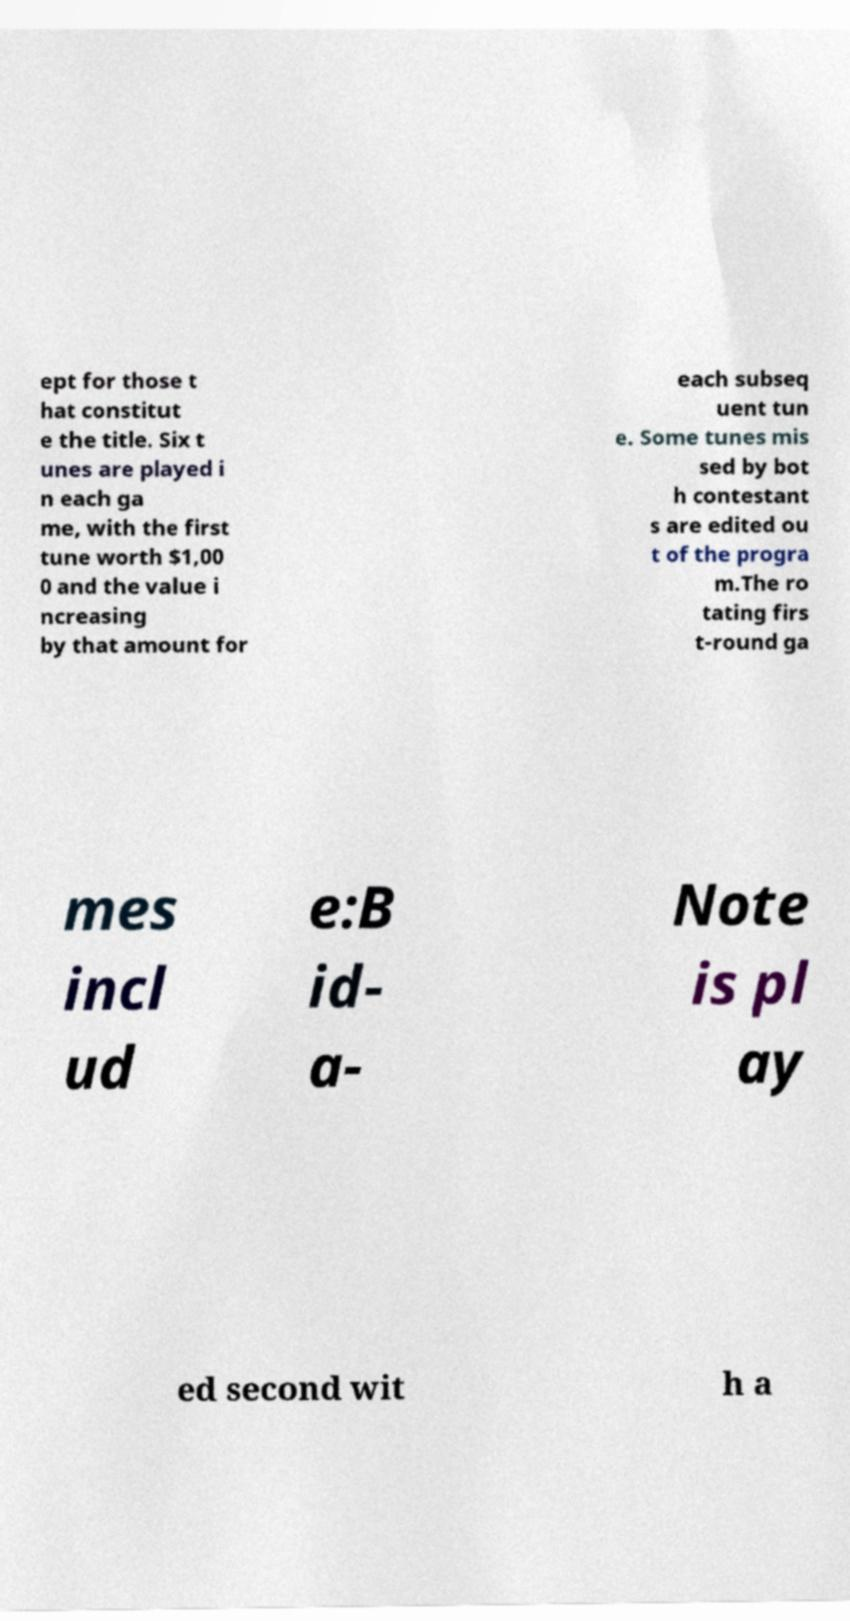I need the written content from this picture converted into text. Can you do that? ept for those t hat constitut e the title. Six t unes are played i n each ga me, with the first tune worth $1,00 0 and the value i ncreasing by that amount for each subseq uent tun e. Some tunes mis sed by bot h contestant s are edited ou t of the progra m.The ro tating firs t-round ga mes incl ud e:B id- a- Note is pl ay ed second wit h a 